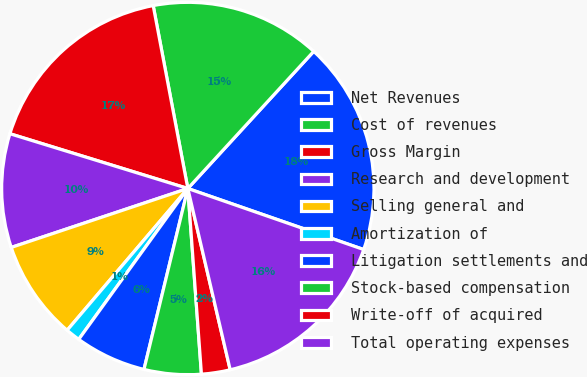Convert chart. <chart><loc_0><loc_0><loc_500><loc_500><pie_chart><fcel>Net Revenues<fcel>Cost of revenues<fcel>Gross Margin<fcel>Research and development<fcel>Selling general and<fcel>Amortization of<fcel>Litigation settlements and<fcel>Stock-based compensation<fcel>Write-off of acquired<fcel>Total operating expenses<nl><fcel>18.5%<fcel>14.8%<fcel>17.27%<fcel>9.88%<fcel>8.65%<fcel>1.26%<fcel>6.18%<fcel>4.95%<fcel>2.49%<fcel>16.03%<nl></chart> 